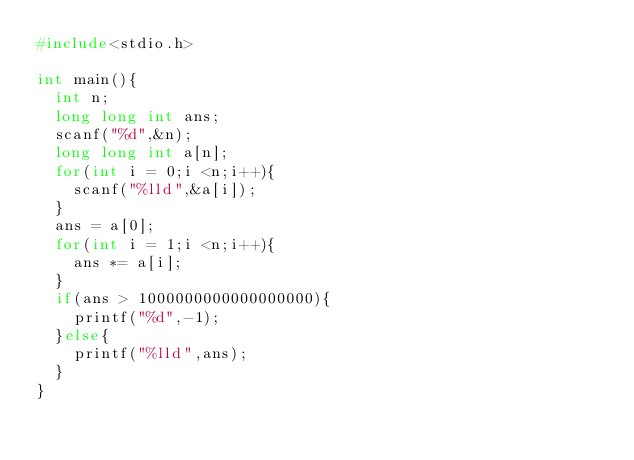<code> <loc_0><loc_0><loc_500><loc_500><_C_>#include<stdio.h>

int main(){
  int n;
  long long int ans;
  scanf("%d",&n);
  long long int a[n];  
  for(int i = 0;i <n;i++){
    scanf("%lld",&a[i]);
  }
  ans = a[0];
  for(int i = 1;i <n;i++){
    ans *= a[i];
  }
  if(ans > 1000000000000000000){
    printf("%d",-1);
  }else{
    printf("%lld",ans);
  }
}
</code> 